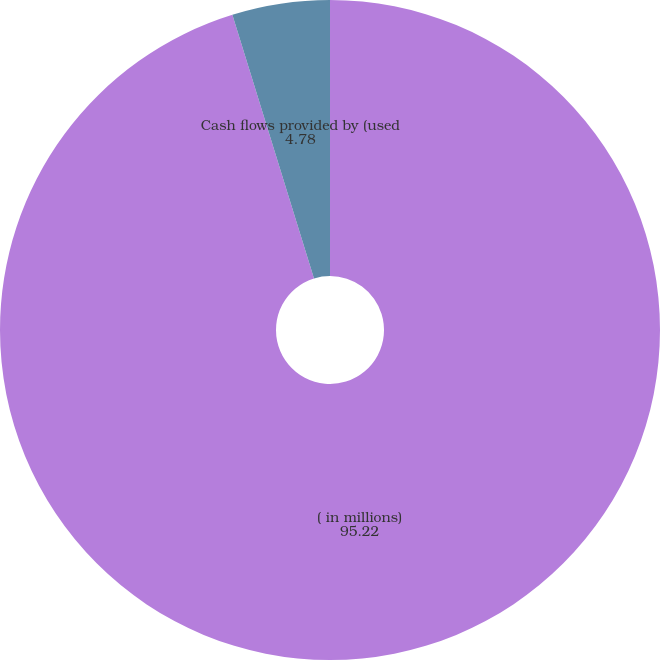Convert chart. <chart><loc_0><loc_0><loc_500><loc_500><pie_chart><fcel>( in millions)<fcel>Cash flows provided by (used<nl><fcel>95.22%<fcel>4.78%<nl></chart> 